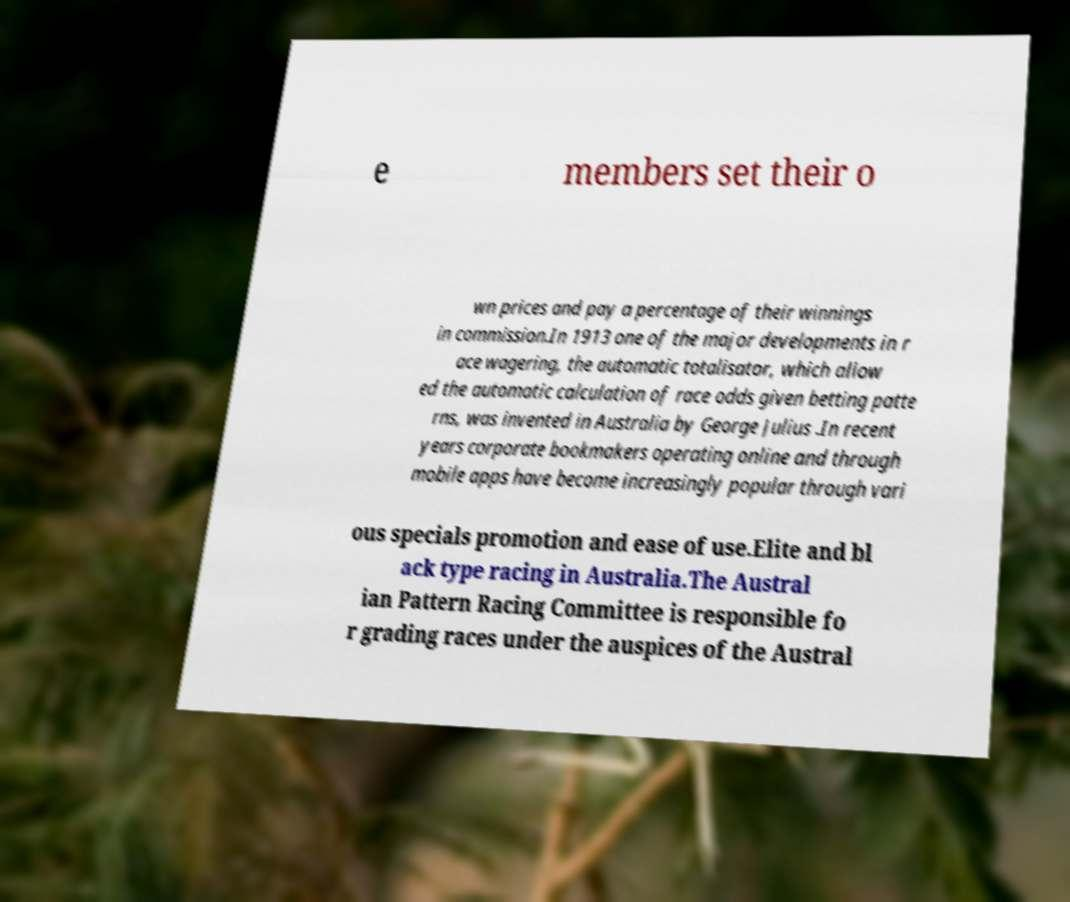Can you accurately transcribe the text from the provided image for me? e members set their o wn prices and pay a percentage of their winnings in commission.In 1913 one of the major developments in r ace wagering, the automatic totalisator, which allow ed the automatic calculation of race odds given betting patte rns, was invented in Australia by George Julius .In recent years corporate bookmakers operating online and through mobile apps have become increasingly popular through vari ous specials promotion and ease of use.Elite and bl ack type racing in Australia.The Austral ian Pattern Racing Committee is responsible fo r grading races under the auspices of the Austral 